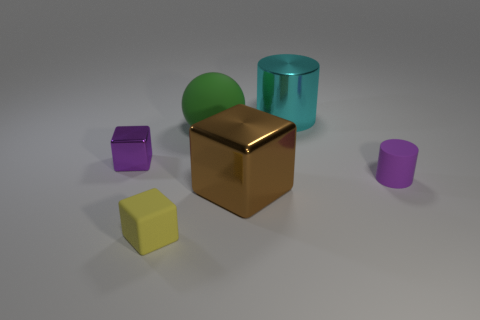Is there a tiny block that has the same material as the big cylinder?
Offer a terse response. Yes. What is the material of the ball that is the same size as the brown block?
Provide a short and direct response. Rubber. There is a tiny purple object behind the tiny purple thing in front of the tiny purple metallic thing; what is it made of?
Offer a terse response. Metal. There is a thing to the left of the rubber cube; does it have the same shape as the tiny yellow rubber thing?
Offer a very short reply. Yes. What is the color of the cylinder that is made of the same material as the big block?
Offer a terse response. Cyan. What is the material of the tiny purple thing in front of the small purple shiny object?
Your answer should be very brief. Rubber. Do the brown metallic thing and the purple object to the left of the big green sphere have the same shape?
Offer a terse response. Yes. There is a block that is both behind the yellow thing and in front of the purple cylinder; what is it made of?
Ensure brevity in your answer.  Metal. What color is the metal cube that is the same size as the purple cylinder?
Give a very brief answer. Purple. Are the yellow cube and the cube that is on the left side of the yellow cube made of the same material?
Give a very brief answer. No. 